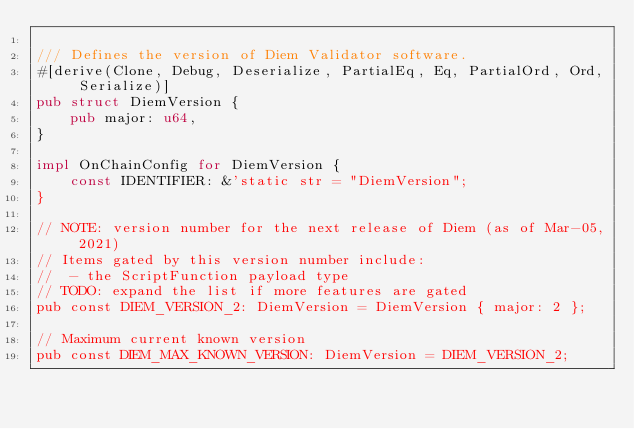<code> <loc_0><loc_0><loc_500><loc_500><_Rust_>
/// Defines the version of Diem Validator software.
#[derive(Clone, Debug, Deserialize, PartialEq, Eq, PartialOrd, Ord, Serialize)]
pub struct DiemVersion {
    pub major: u64,
}

impl OnChainConfig for DiemVersion {
    const IDENTIFIER: &'static str = "DiemVersion";
}

// NOTE: version number for the next release of Diem (as of Mar-05, 2021)
// Items gated by this version number include:
//  - the ScriptFunction payload type
// TODO: expand the list if more features are gated
pub const DIEM_VERSION_2: DiemVersion = DiemVersion { major: 2 };

// Maximum current known version
pub const DIEM_MAX_KNOWN_VERSION: DiemVersion = DIEM_VERSION_2;
</code> 